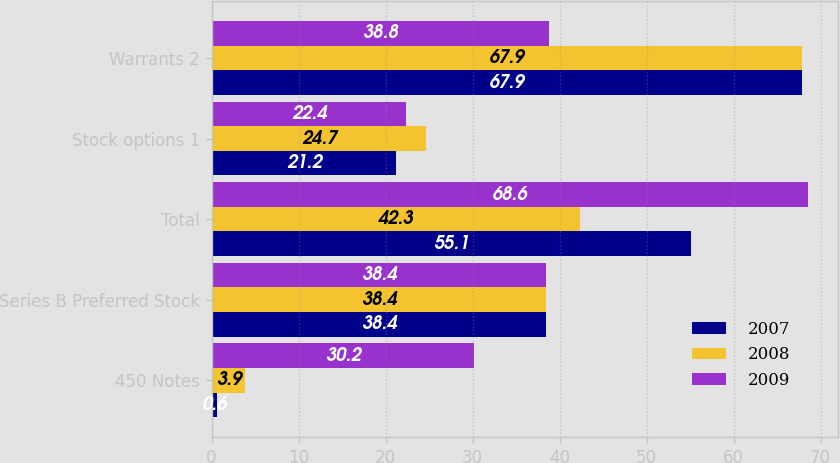<chart> <loc_0><loc_0><loc_500><loc_500><stacked_bar_chart><ecel><fcel>450 Notes<fcel>Series B Preferred Stock<fcel>Total<fcel>Stock options 1<fcel>Warrants 2<nl><fcel>2007<fcel>0.6<fcel>38.4<fcel>55.1<fcel>21.2<fcel>67.9<nl><fcel>2008<fcel>3.9<fcel>38.4<fcel>42.3<fcel>24.7<fcel>67.9<nl><fcel>2009<fcel>30.2<fcel>38.4<fcel>68.6<fcel>22.4<fcel>38.8<nl></chart> 